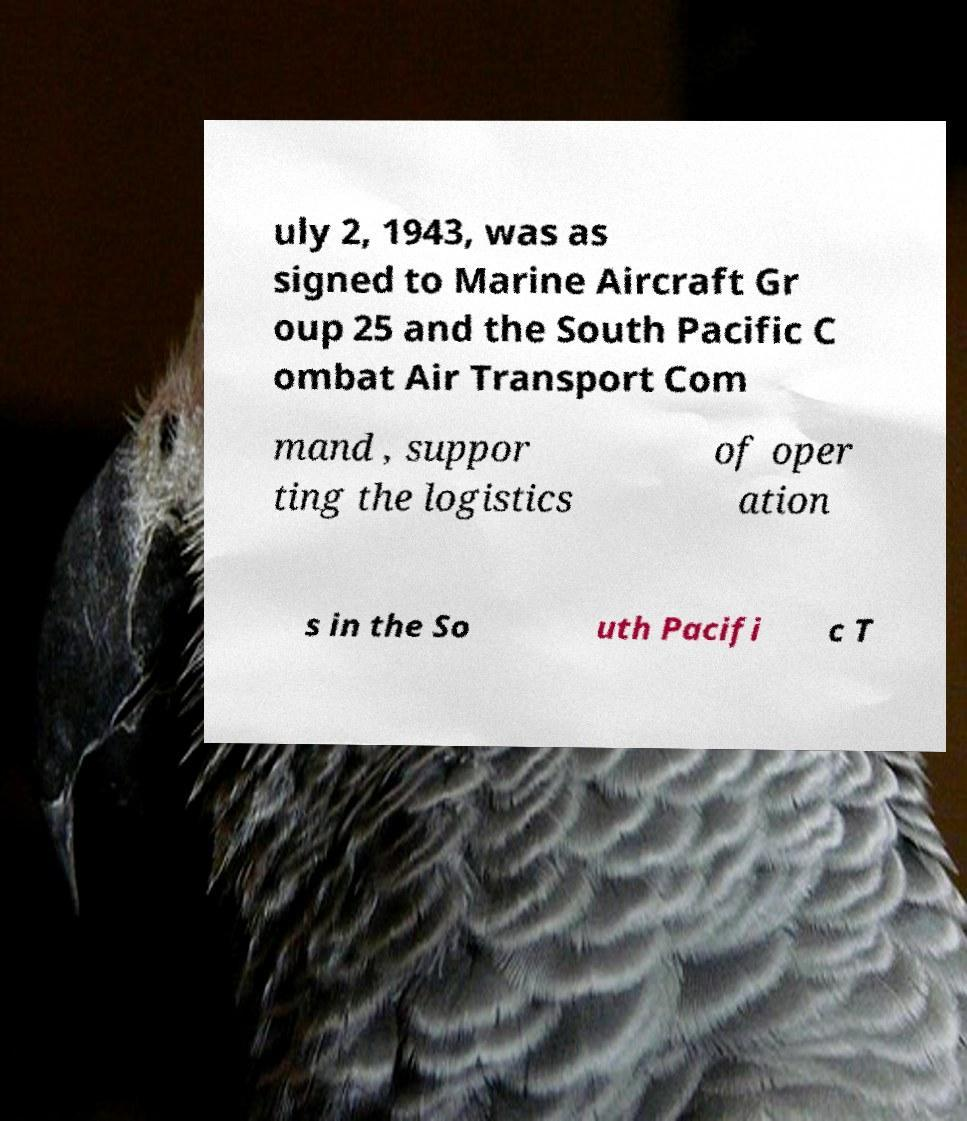I need the written content from this picture converted into text. Can you do that? uly 2, 1943, was as signed to Marine Aircraft Gr oup 25 and the South Pacific C ombat Air Transport Com mand , suppor ting the logistics of oper ation s in the So uth Pacifi c T 